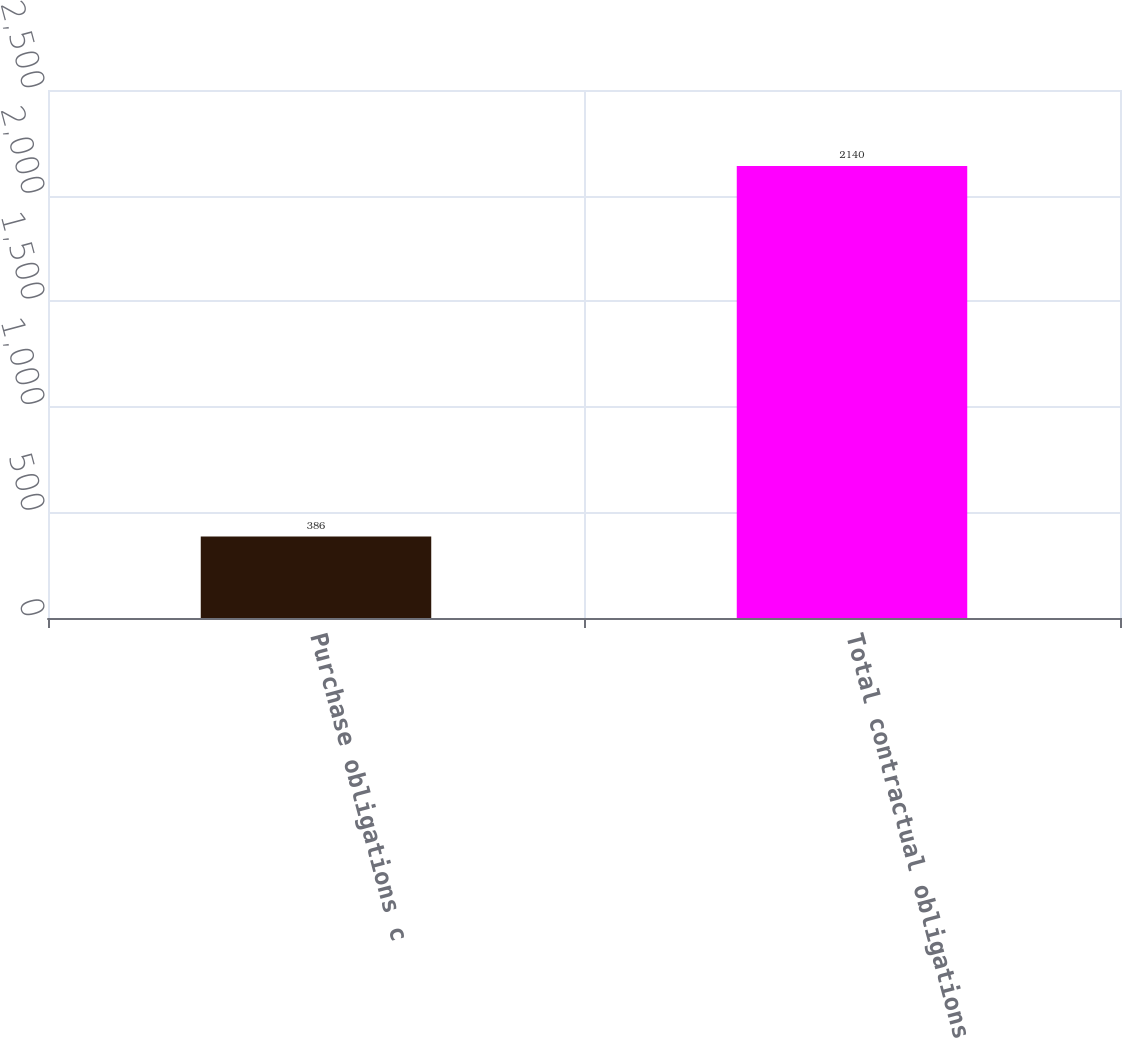<chart> <loc_0><loc_0><loc_500><loc_500><bar_chart><fcel>Purchase obligations c<fcel>Total contractual obligations<nl><fcel>386<fcel>2140<nl></chart> 